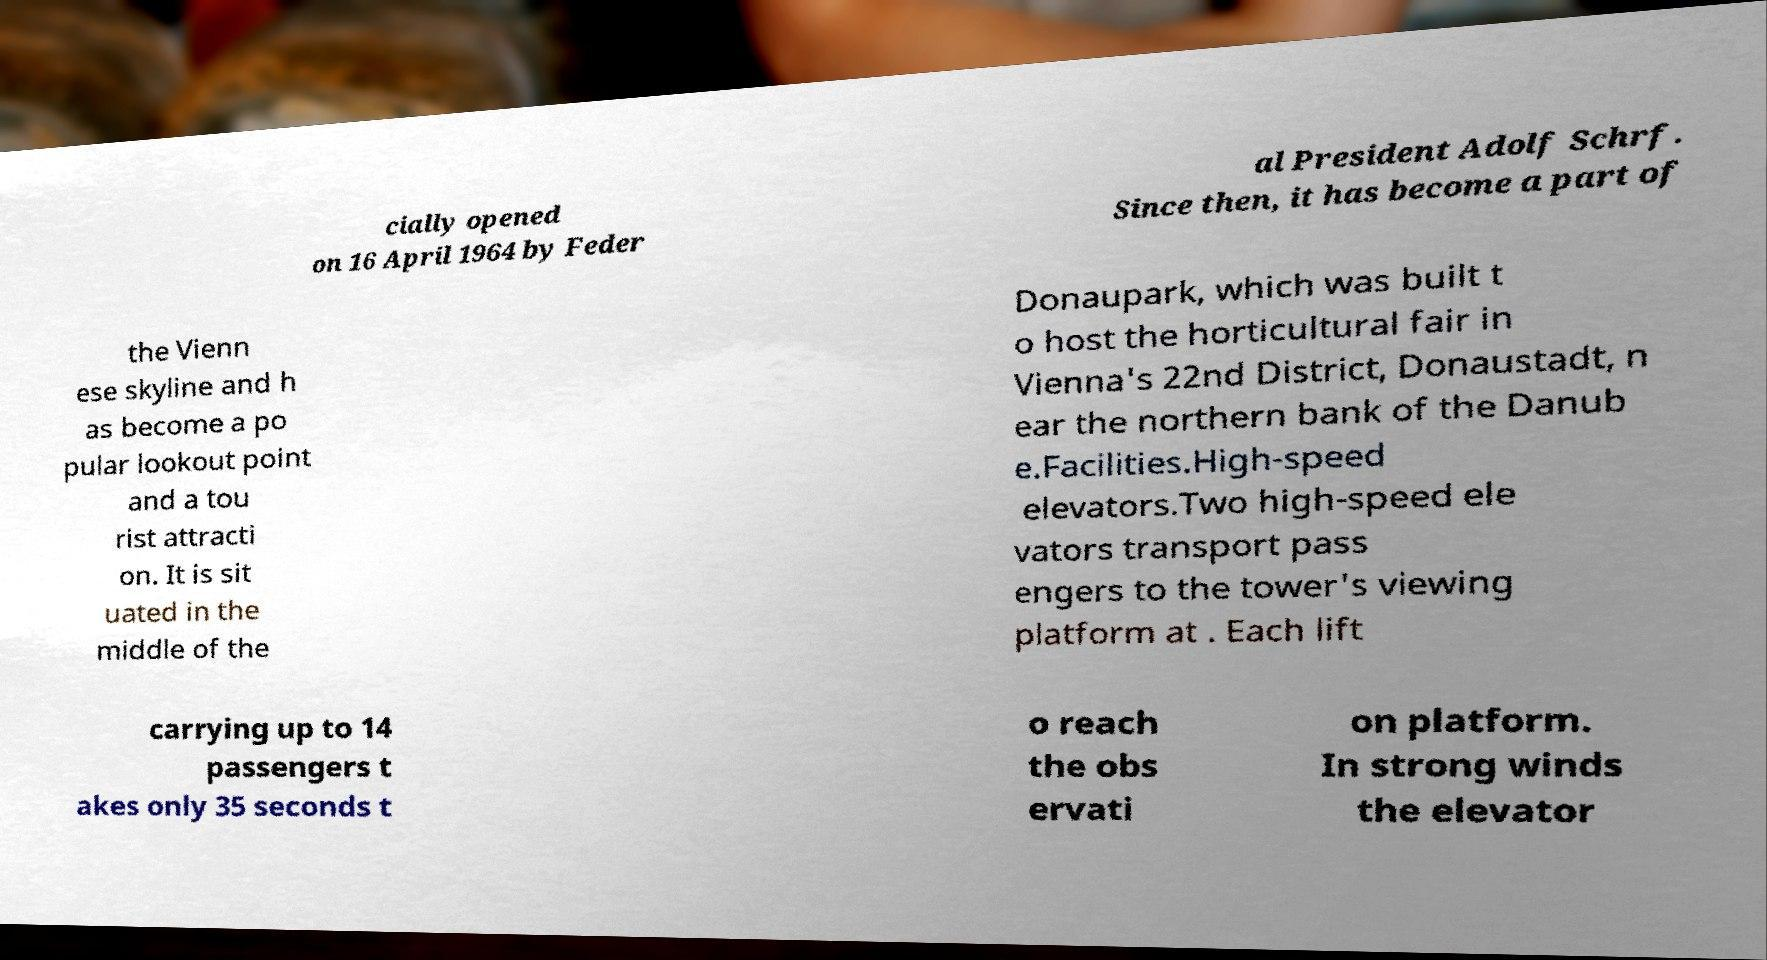I need the written content from this picture converted into text. Can you do that? cially opened on 16 April 1964 by Feder al President Adolf Schrf. Since then, it has become a part of the Vienn ese skyline and h as become a po pular lookout point and a tou rist attracti on. It is sit uated in the middle of the Donaupark, which was built t o host the horticultural fair in Vienna's 22nd District, Donaustadt, n ear the northern bank of the Danub e.Facilities.High-speed elevators.Two high-speed ele vators transport pass engers to the tower's viewing platform at . Each lift carrying up to 14 passengers t akes only 35 seconds t o reach the obs ervati on platform. In strong winds the elevator 